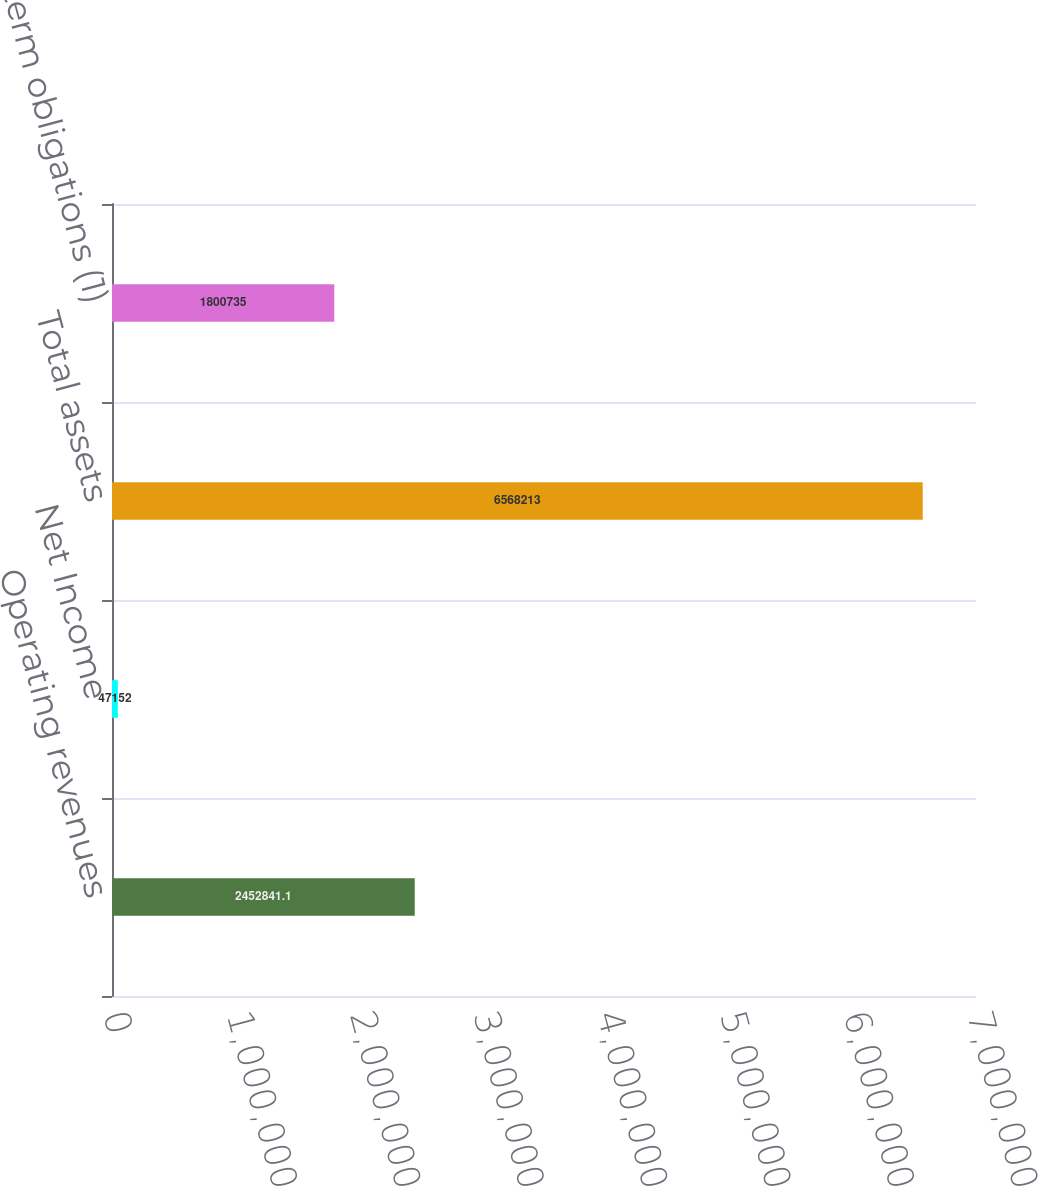<chart> <loc_0><loc_0><loc_500><loc_500><bar_chart><fcel>Operating revenues<fcel>Net Income<fcel>Total assets<fcel>Long-term obligations (1)<nl><fcel>2.45284e+06<fcel>47152<fcel>6.56821e+06<fcel>1.80074e+06<nl></chart> 